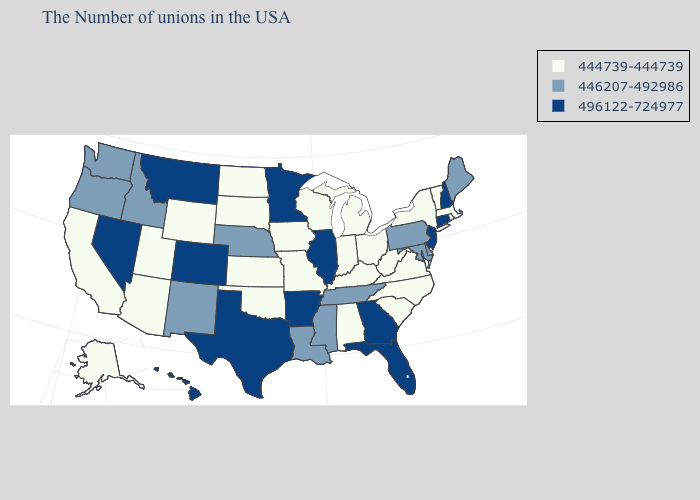Name the states that have a value in the range 444739-444739?
Write a very short answer. Massachusetts, Rhode Island, Vermont, New York, Virginia, North Carolina, South Carolina, West Virginia, Ohio, Michigan, Kentucky, Indiana, Alabama, Wisconsin, Missouri, Iowa, Kansas, Oklahoma, South Dakota, North Dakota, Wyoming, Utah, Arizona, California, Alaska. Does the first symbol in the legend represent the smallest category?
Write a very short answer. Yes. Does Mississippi have the same value as Maryland?
Short answer required. Yes. What is the value of Utah?
Be succinct. 444739-444739. What is the highest value in the West ?
Write a very short answer. 496122-724977. Name the states that have a value in the range 446207-492986?
Short answer required. Maine, Delaware, Maryland, Pennsylvania, Tennessee, Mississippi, Louisiana, Nebraska, New Mexico, Idaho, Washington, Oregon. What is the highest value in the USA?
Short answer required. 496122-724977. Name the states that have a value in the range 446207-492986?
Write a very short answer. Maine, Delaware, Maryland, Pennsylvania, Tennessee, Mississippi, Louisiana, Nebraska, New Mexico, Idaho, Washington, Oregon. Name the states that have a value in the range 446207-492986?
Quick response, please. Maine, Delaware, Maryland, Pennsylvania, Tennessee, Mississippi, Louisiana, Nebraska, New Mexico, Idaho, Washington, Oregon. Among the states that border Minnesota , which have the highest value?
Concise answer only. Wisconsin, Iowa, South Dakota, North Dakota. What is the lowest value in states that border New Mexico?
Concise answer only. 444739-444739. What is the value of Hawaii?
Be succinct. 496122-724977. Does the first symbol in the legend represent the smallest category?
Give a very brief answer. Yes. What is the lowest value in the West?
Short answer required. 444739-444739. 